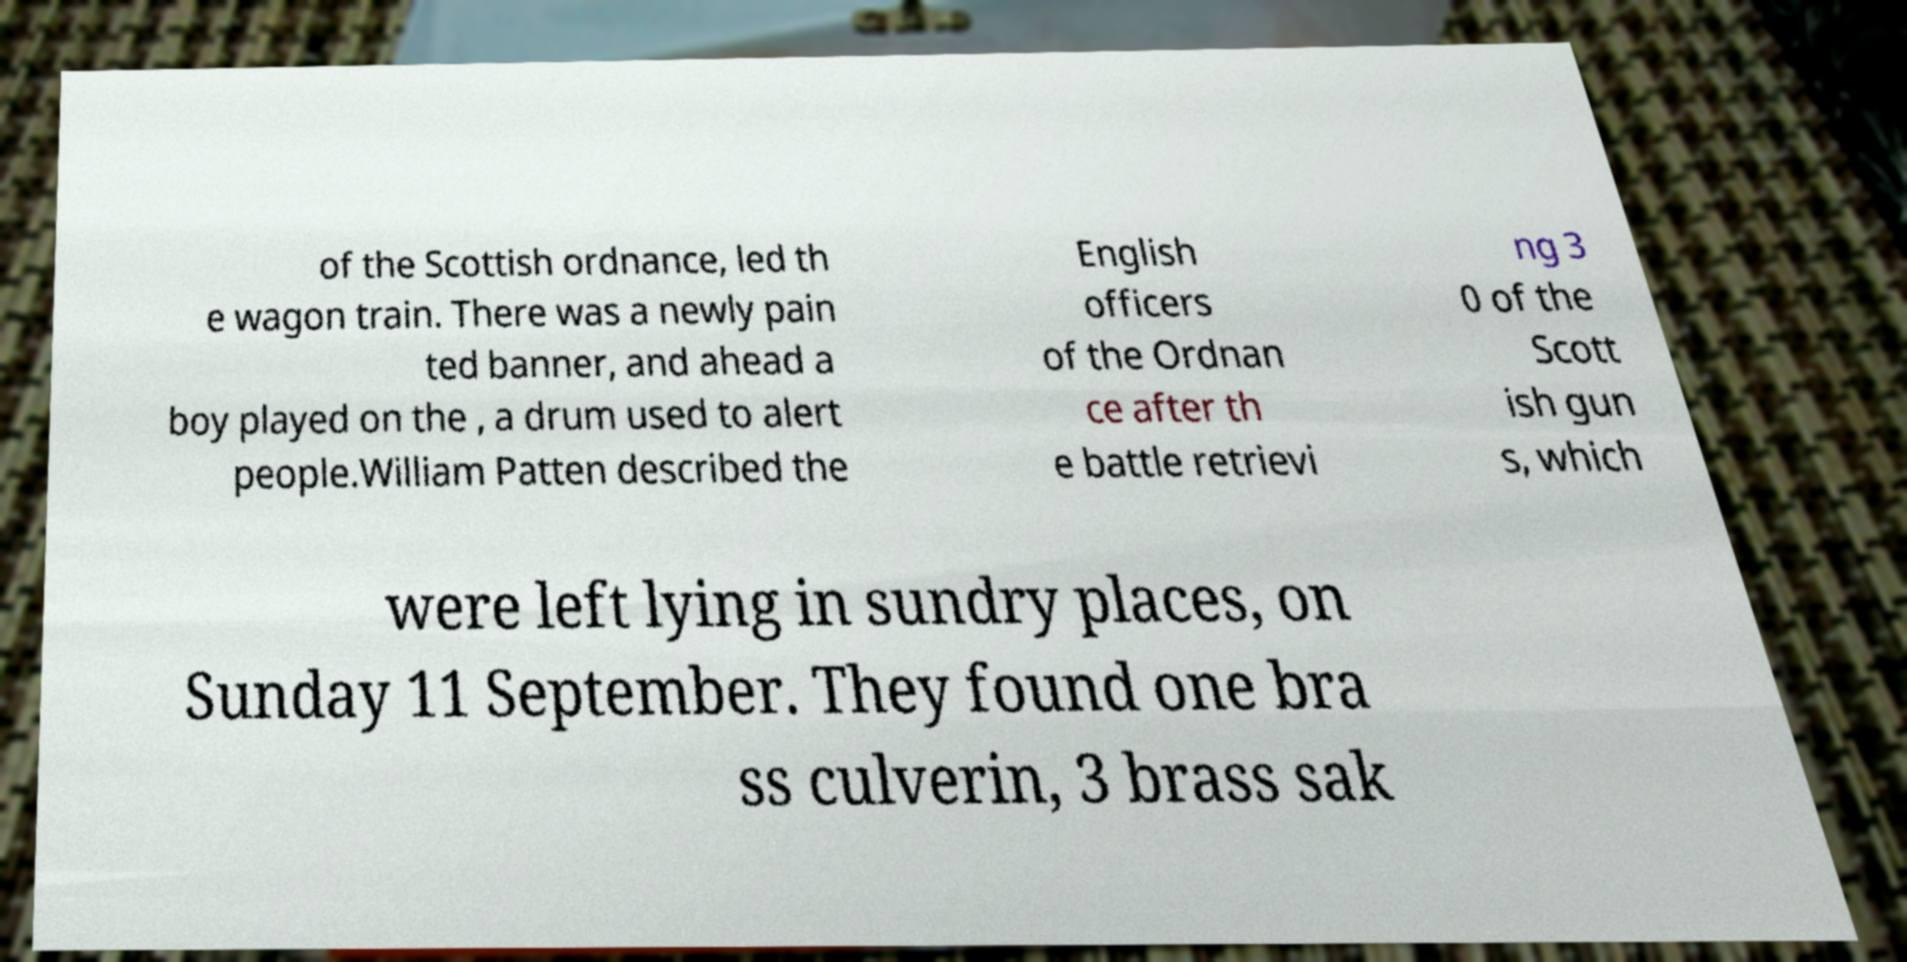I need the written content from this picture converted into text. Can you do that? of the Scottish ordnance, led th e wagon train. There was a newly pain ted banner, and ahead a boy played on the , a drum used to alert people.William Patten described the English officers of the Ordnan ce after th e battle retrievi ng 3 0 of the Scott ish gun s, which were left lying in sundry places, on Sunday 11 September. They found one bra ss culverin, 3 brass sak 